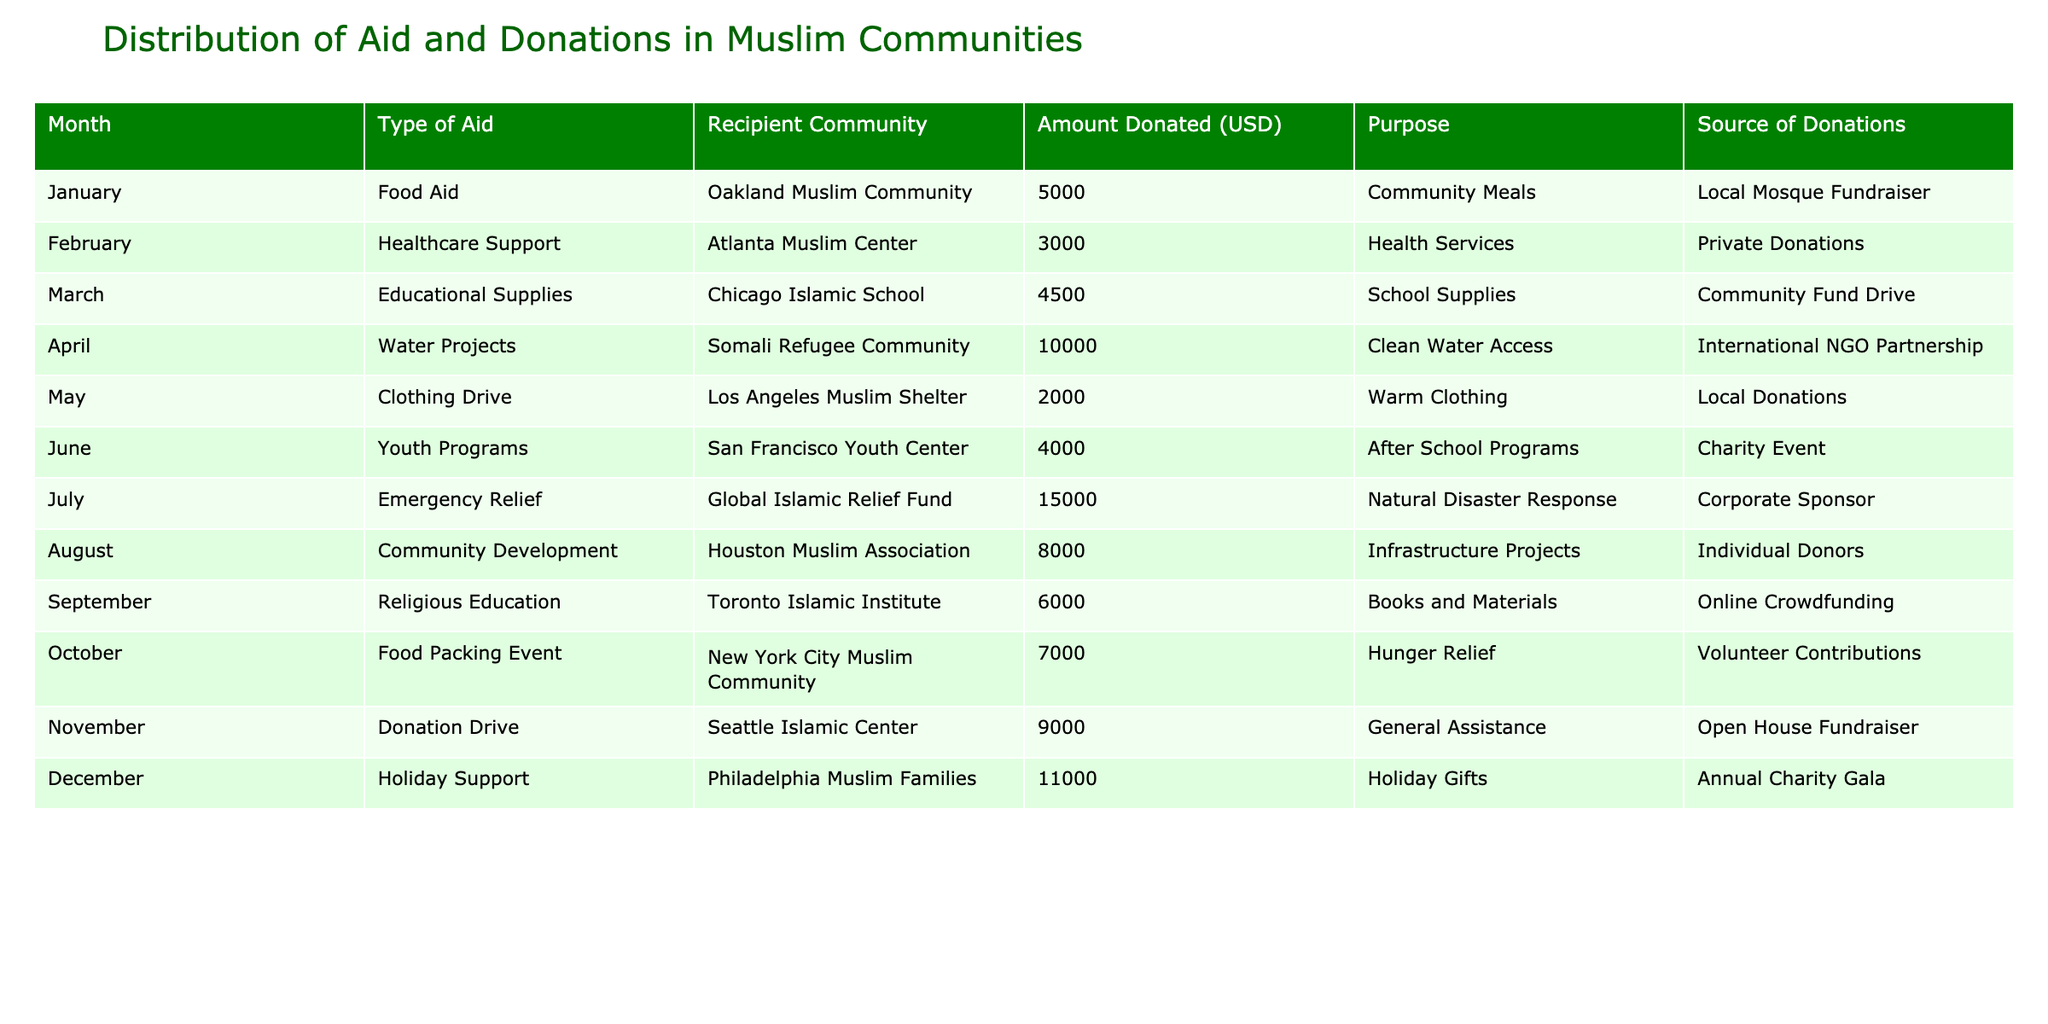What type of aid was provided to the Oakland Muslim Community? The table lists the aid provided to each community along with the type. Looking at the row for January, the type of aid provided to the Oakland Muslim Community is food aid.
Answer: Food Aid Which month had the highest amount donated, and what was the purpose of that donation? By examining the Amount Donated column, the highest figure is 15,000 in July. The purpose of that donation was for natural disaster response as noted in the Purpose column.
Answer: July, Emergency Relief What is the total amount donated for educational supplies across all communities? The table lists one entry for educational supplies, which is 4,500 for the Chicago Islamic School in March, and there are no other educational supply donations noted in the table. Therefore, the total amount is simply 4,500.
Answer: 4500 True or False: The San Francisco Youth Center received more aid than the Atlanta Muslim Center. The San Francisco Youth Center received 4,000, while the Atlanta Muslim Center received 3,000. Since 4,000 is greater than 3,000, this statement is true.
Answer: True What is the average amount donated for community development and emergency relief combined? The Community Development aid for August is 8,000 and the Emergency Relief aids for July total 15,000. Adding these gives 8,000 + 15,000 = 23,000. To find the average, divide by 2 (as there are two amounts): 23,000 / 2 = 11,500.
Answer: 11500 Which community received donations for clothing, and how much was donated? Looking at the table, the Los Angeles Muslim Shelter received donations for clothing in May, amounting to 2,000.
Answer: Los Angeles Muslim Shelter, 2000 Was there any aid provided for religious education in December? The table indicates that November was the month for religious education with a donation of 6,000 to the Toronto Islamic Institute; December had holiday support instead. Thus, the answer is no.
Answer: No What was the total financial support provided to the Somali Refugee Community? In April, the Somali Refugee Community received aid amounting to 10,000 for clean water access. There are no other entries for donations to this community, hence the total is 10,000.
Answer: 10000 How much more was donated to the Philadelphia Muslim Families than to the Atlanta Muslim Center? The donation for the Philadelphia Muslim Families in December is 11,000, and for the Atlanta Muslim Center in February, it is 3,000. Subtracting the latter from the former gives 11,000 - 3,000 = 8,000.
Answer: 8000 